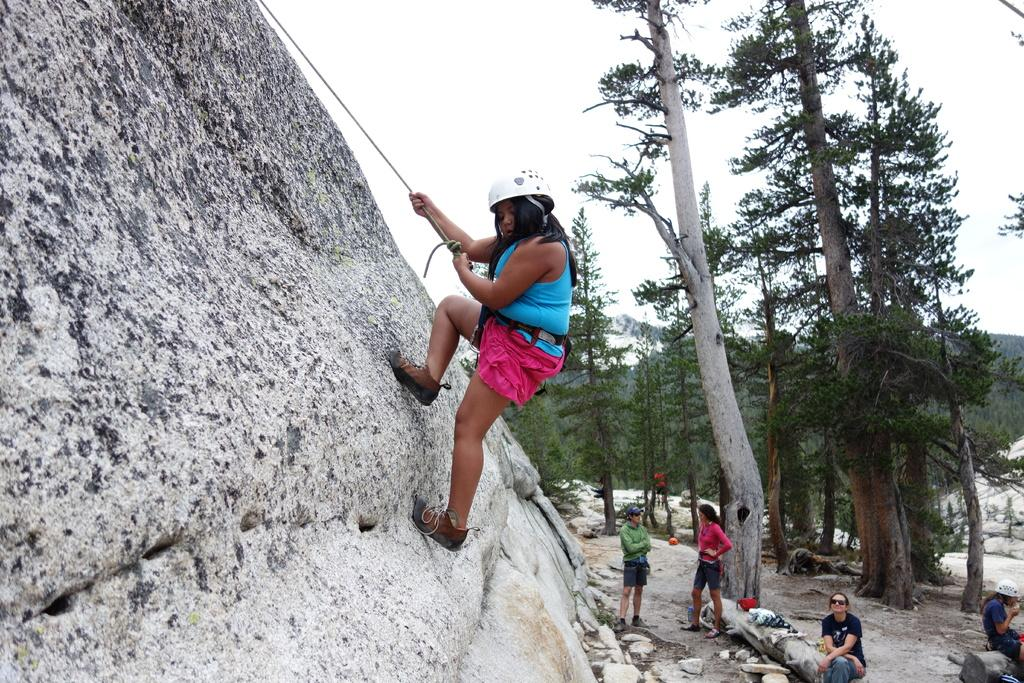What is the person on the left side of the image doing? The person on the left side of the image is climbing a hill. What can be seen on the right side of the image? There are people, stones, clothes, and soil present on the right side of the image. What type of vegetation is in the center of the image? There are trees in the center of the image. What is visible in the background of the image? The sky is visible in the background of the image. What type of thread is being used by the person climbing the hill in the image? There is no thread visible in the image; the person is simply climbing the hill. What type of coat is being worn by the trees in the center of the image? Trees do not wear coats; they are natural vegetation and are not depicted wearing clothing in the image. 